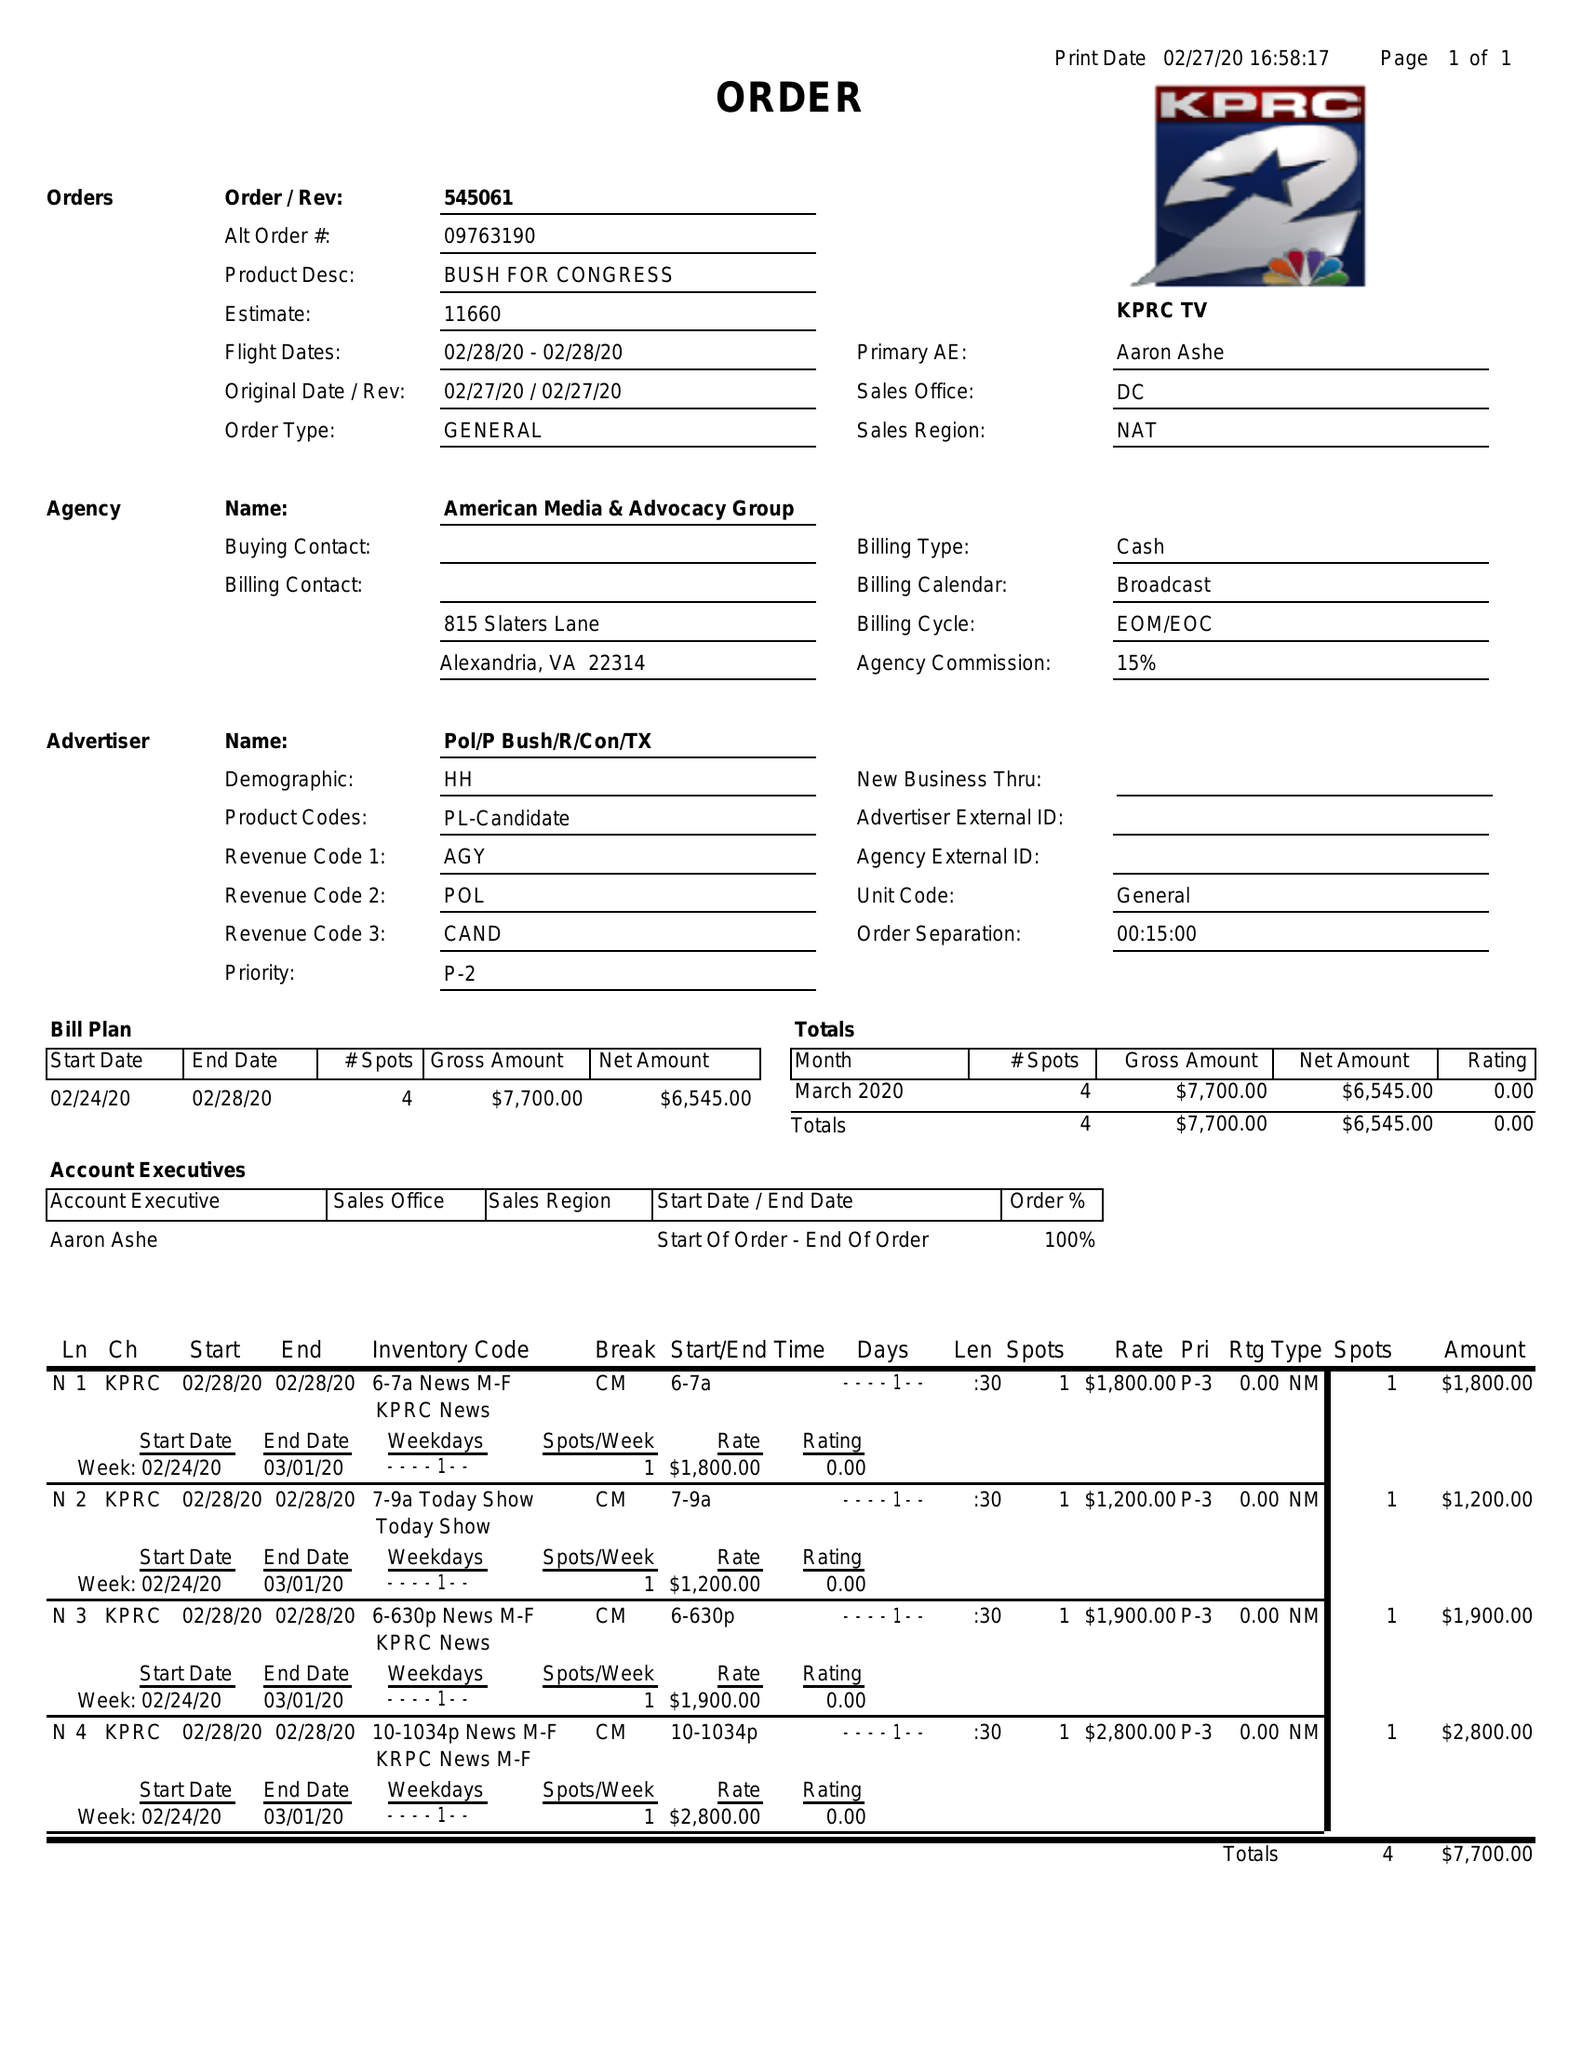What is the value for the gross_amount?
Answer the question using a single word or phrase. 7700.00 